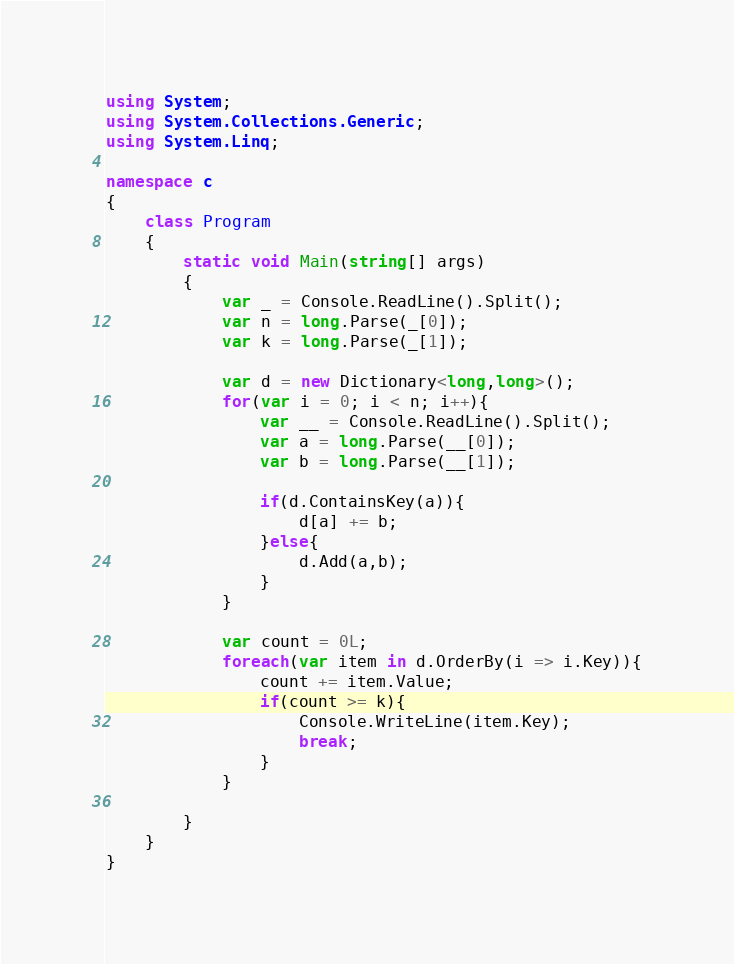Convert code to text. <code><loc_0><loc_0><loc_500><loc_500><_C#_>using System;
using System.Collections.Generic;
using System.Linq;

namespace c
{
    class Program
    {
        static void Main(string[] args)
        {
            var _ = Console.ReadLine().Split();
            var n = long.Parse(_[0]);
            var k = long.Parse(_[1]);

            var d = new Dictionary<long,long>();
            for(var i = 0; i < n; i++){
                var __ = Console.ReadLine().Split();
                var a = long.Parse(__[0]);
                var b = long.Parse(__[1]);

                if(d.ContainsKey(a)){
                    d[a] += b;
                }else{
                    d.Add(a,b);
                }
            }

            var count = 0L;
            foreach(var item in d.OrderBy(i => i.Key)){
                count += item.Value;
                if(count >= k){
                    Console.WriteLine(item.Key);
                    break;
                }
            }

        }
    }
}
</code> 